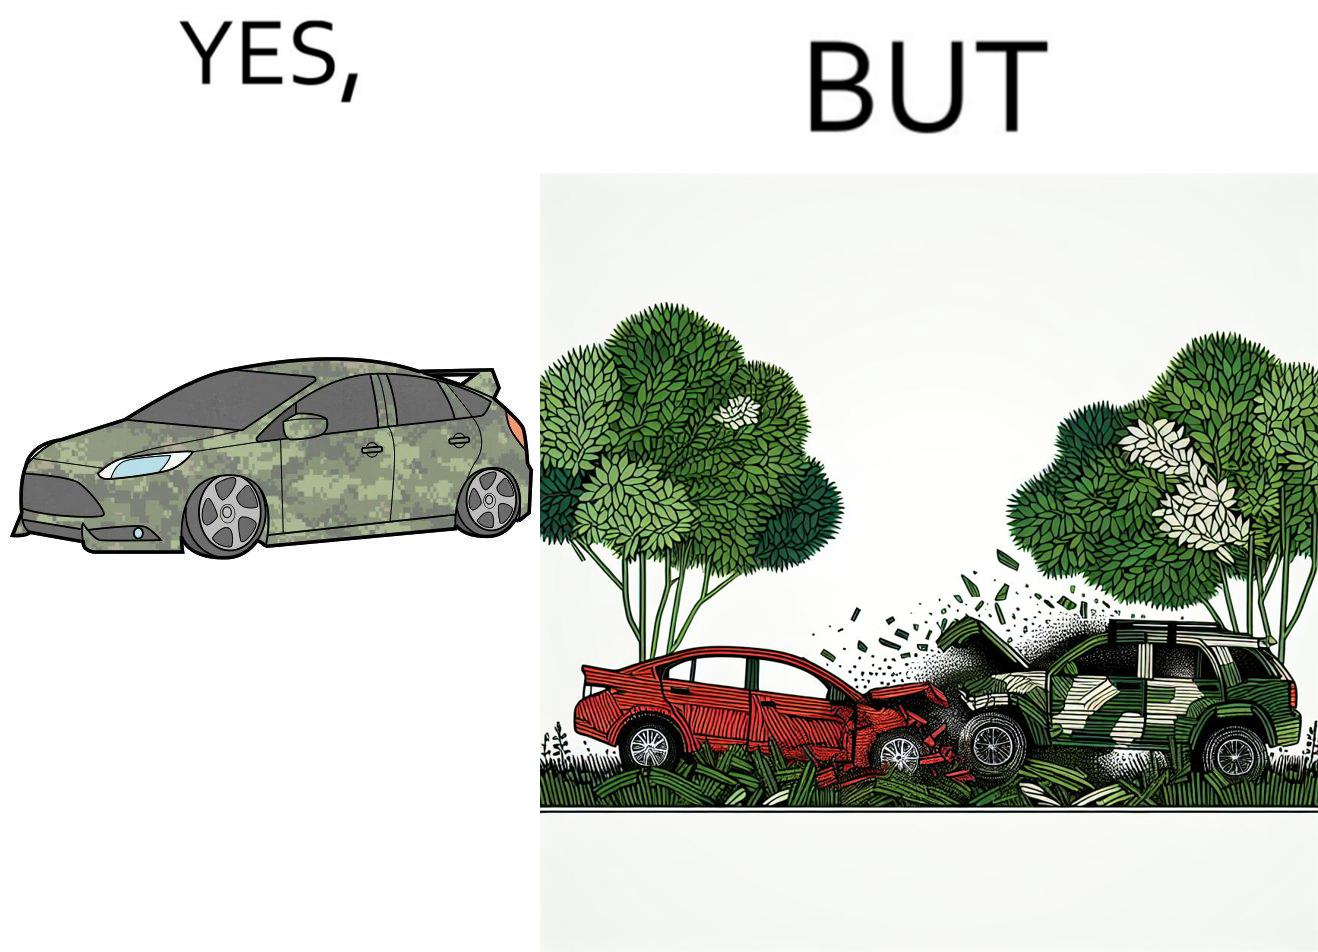What do you see in each half of this image? In the left part of the image: a car painted in a camouflage color In the right part of the image: a red color car crashing into a camouflage color car due to the background of green plants 